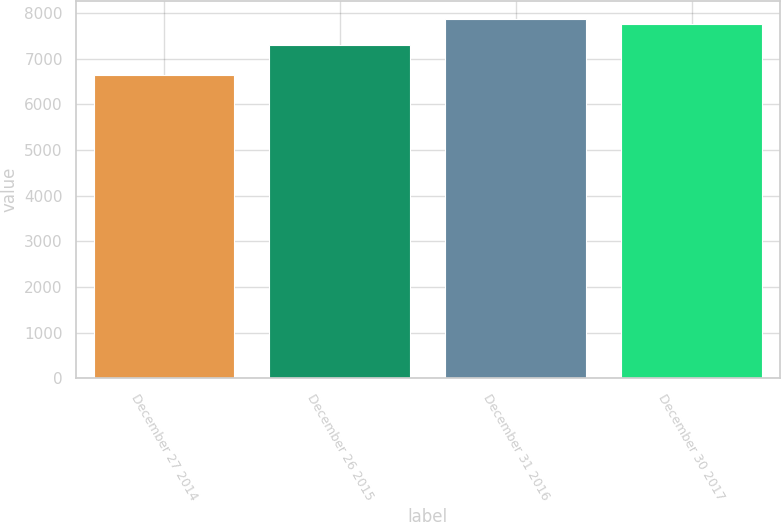Convert chart to OTSL. <chart><loc_0><loc_0><loc_500><loc_500><bar_chart><fcel>December 27 2014<fcel>December 26 2015<fcel>December 31 2016<fcel>December 30 2017<nl><fcel>6646<fcel>7306<fcel>7875.7<fcel>7760<nl></chart> 